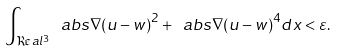<formula> <loc_0><loc_0><loc_500><loc_500>\int _ { \Re a l ^ { 3 } } \ a b s { \nabla ( u - w ) } ^ { 2 } + \ a b s { \nabla ( u - w ) } ^ { 4 } d x < \varepsilon .</formula> 